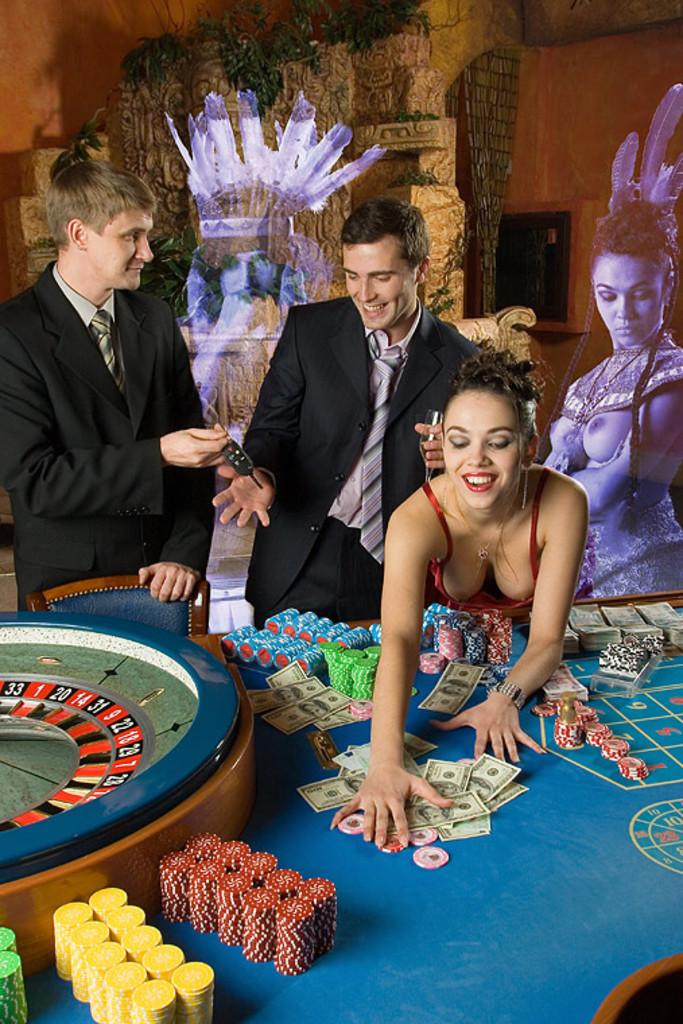How many people are in the image? There are persons in the image, but the exact number cannot be determined from the provided facts. What is on the table in the image? There are cards and coins on the table in the image. What is the seating arrangement like in the image? There is a chair in the image, which suggests that at least one person is seated. What can be seen in the background of the image? There is a wall and plants in the background of the image. What type of plastic is covering the table in the image? There is no mention of plastic covering the table in the image. What is the approval rating of the person in the image? There is no indication of any person's approval rating in the image. 